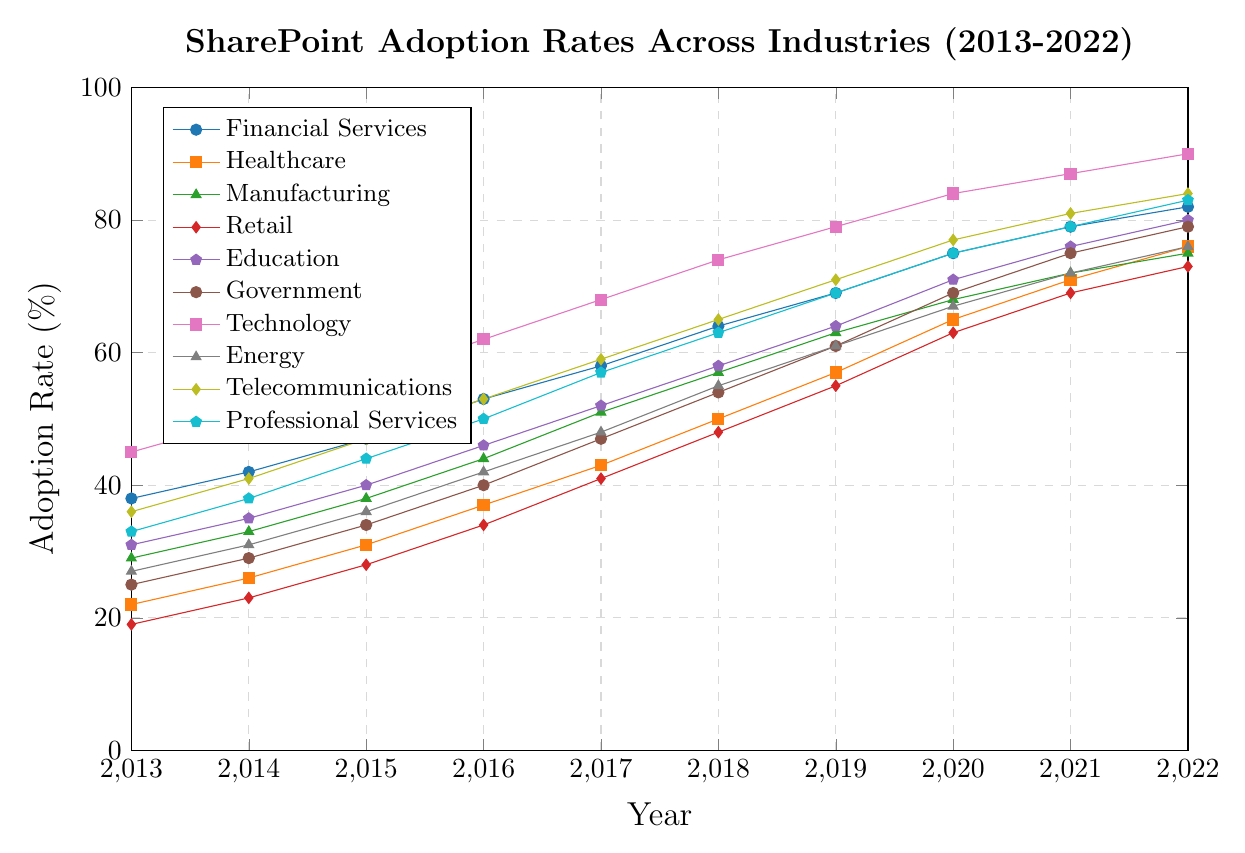What is the adoption rate of SharePoint in the Healthcare industry in 2020? To find the adoption rate of SharePoint in the Healthcare industry in 2020, locate Healthcare on the legend, then find the corresponding data point for the year 2020 on the x-axis.
Answer: 65% Which industry had the highest adoption rate of SharePoint in 2015? Compare the adoption rates for all industries in 2015 by visually following the 2015 gridline and checking each series. The highest data point along this line is for the Technology industry.
Answer: Technology Between 2018 and 2020, which industry saw the largest percentage increase in SharePoint adoption? Calculate the percentage increase for each industry between 2018 and 2020 by finding the difference in adoption rates for these years, then compare these values. Technology has the highest increase (84% - 74% = 10%).
Answer: Technology What is the average adoption rate of SharePoint across all industries in 2022? Add up the adoption rates of all industries in 2022, then divide by the number of industries (10). (82 + 76 + 75 + 73 + 80 + 79 + 90 + 76 + 84 + 83) / 10 = 79.8%
Answer: 79.8% Which two industries had the closest adoption rates to each other in 2017? Compare the adoption rates of all industries in 2017, noting the pairs that have the smallest difference. The closest rates in 2017 are for Telecommunications (59%) and Healthcare (57%).
Answer: Healthcare and Telecommunications Is the adoption rate growth for the Professional Services industry from 2013 to 2015 greater than that for the Education industry over the same period? Calculate the growth by finding the difference between adoption rates from 2013 to 2015 for each industry: Professional Services (44% - 33% = 11%), Education (40% - 31% = 9%). Compare these values.
Answer: Yes Between 2015 and 2019, which industry had the most consistent increase in SharePoint adoption? For each industry, calculate the increase between consecutive years from 2015 to 2019. The industry with the smallest variation in year-on-year increases is the most consistent. The Education industry has consistent growth.
Answer: Education What was the drop or increase in the adoption rate of SharePoint in the Financial Services industry from 2016 to 2017? Subtract the adoption rate in 2016 from that in 2017 to find the change (58% - 53% = 5%).
Answer: Increase of 5% Which industry had the lowest starting adoption rate in 2013, and what was that rate? Compare the adoption rates for all industries in 2013 and identify the lowest value. Retail has the lowest starting adoption rate at 19%.
Answer: Retail, 19% Did any industry reach or exceed a 90% adoption rate by 2022? If so, which ones? Check the adoption rates for all industries in 2022 and identify any that are 90% or above. Technology reached 90%.
Answer: Technology 